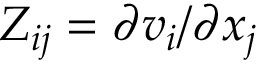Convert formula to latex. <formula><loc_0><loc_0><loc_500><loc_500>Z _ { i j } = \partial v _ { i } / \partial x _ { j }</formula> 